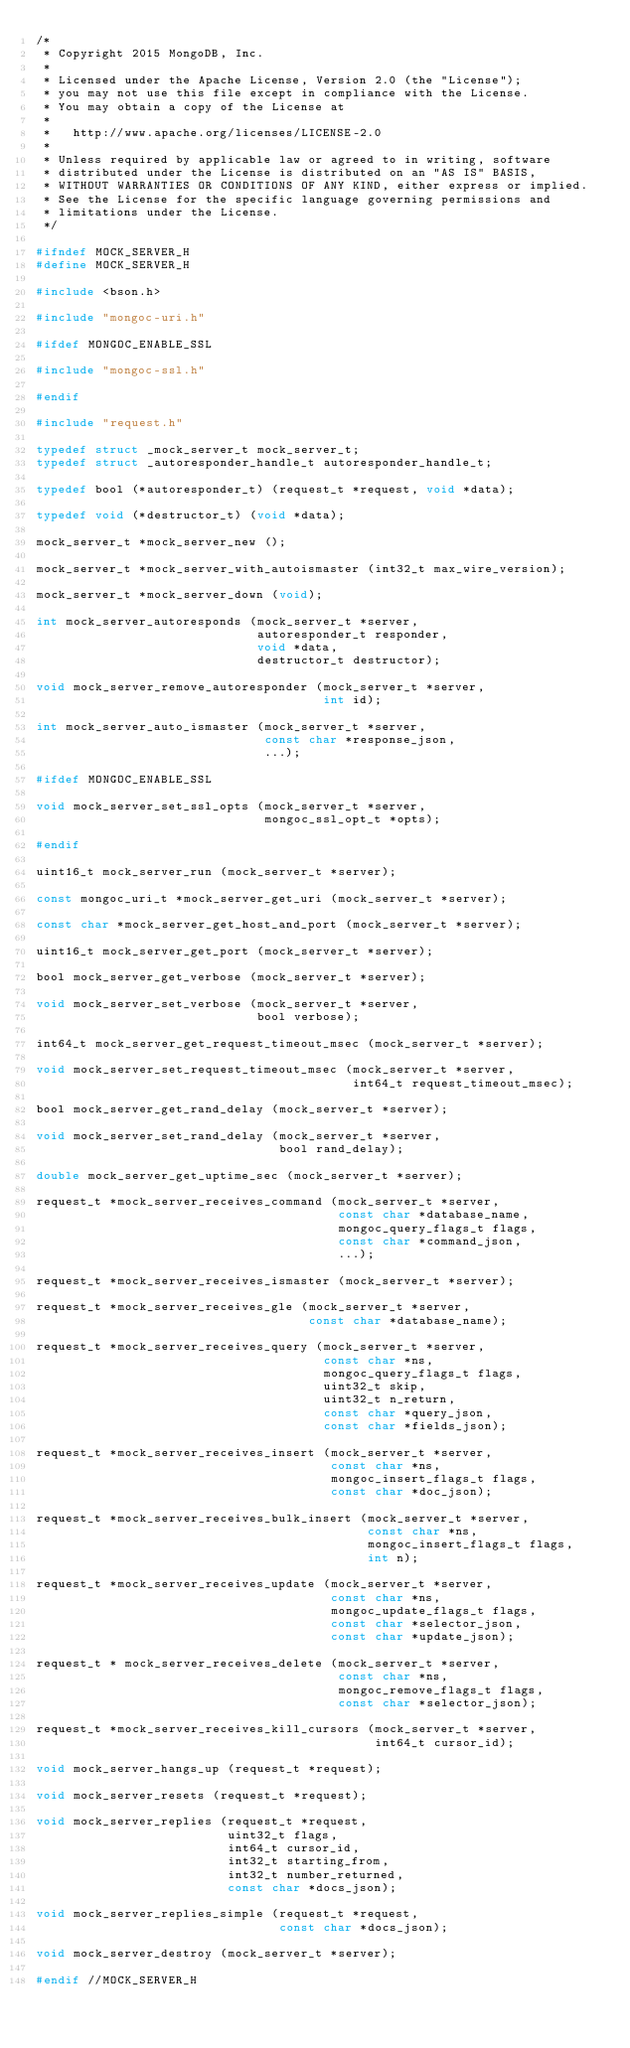<code> <loc_0><loc_0><loc_500><loc_500><_C_>/*
 * Copyright 2015 MongoDB, Inc.
 *
 * Licensed under the Apache License, Version 2.0 (the "License");
 * you may not use this file except in compliance with the License.
 * You may obtain a copy of the License at
 *
 *   http://www.apache.org/licenses/LICENSE-2.0
 *
 * Unless required by applicable law or agreed to in writing, software
 * distributed under the License is distributed on an "AS IS" BASIS,
 * WITHOUT WARRANTIES OR CONDITIONS OF ANY KIND, either express or implied.
 * See the License for the specific language governing permissions and
 * limitations under the License.
 */

#ifndef MOCK_SERVER_H
#define MOCK_SERVER_H

#include <bson.h>

#include "mongoc-uri.h"

#ifdef MONGOC_ENABLE_SSL

#include "mongoc-ssl.h"

#endif

#include "request.h"

typedef struct _mock_server_t mock_server_t;
typedef struct _autoresponder_handle_t autoresponder_handle_t;

typedef bool (*autoresponder_t) (request_t *request, void *data);

typedef void (*destructor_t) (void *data);

mock_server_t *mock_server_new ();

mock_server_t *mock_server_with_autoismaster (int32_t max_wire_version);

mock_server_t *mock_server_down (void);

int mock_server_autoresponds (mock_server_t *server,
                              autoresponder_t responder,
                              void *data,
                              destructor_t destructor);

void mock_server_remove_autoresponder (mock_server_t *server,
                                       int id);

int mock_server_auto_ismaster (mock_server_t *server,
                               const char *response_json,
                               ...);

#ifdef MONGOC_ENABLE_SSL

void mock_server_set_ssl_opts (mock_server_t *server,
                               mongoc_ssl_opt_t *opts);

#endif

uint16_t mock_server_run (mock_server_t *server);

const mongoc_uri_t *mock_server_get_uri (mock_server_t *server);

const char *mock_server_get_host_and_port (mock_server_t *server);

uint16_t mock_server_get_port (mock_server_t *server);

bool mock_server_get_verbose (mock_server_t *server);

void mock_server_set_verbose (mock_server_t *server,
                              bool verbose);

int64_t mock_server_get_request_timeout_msec (mock_server_t *server);

void mock_server_set_request_timeout_msec (mock_server_t *server,
                                           int64_t request_timeout_msec);

bool mock_server_get_rand_delay (mock_server_t *server);

void mock_server_set_rand_delay (mock_server_t *server,
                                 bool rand_delay);

double mock_server_get_uptime_sec (mock_server_t *server);

request_t *mock_server_receives_command (mock_server_t *server,
                                         const char *database_name,
                                         mongoc_query_flags_t flags,
                                         const char *command_json,
                                         ...);

request_t *mock_server_receives_ismaster (mock_server_t *server);

request_t *mock_server_receives_gle (mock_server_t *server,
                                     const char *database_name);

request_t *mock_server_receives_query (mock_server_t *server,
                                       const char *ns,
                                       mongoc_query_flags_t flags,
                                       uint32_t skip,
                                       uint32_t n_return,
                                       const char *query_json,
                                       const char *fields_json);

request_t *mock_server_receives_insert (mock_server_t *server,
                                        const char *ns,
                                        mongoc_insert_flags_t flags,
                                        const char *doc_json);

request_t *mock_server_receives_bulk_insert (mock_server_t *server,
                                             const char *ns,
                                             mongoc_insert_flags_t flags,
                                             int n);

request_t *mock_server_receives_update (mock_server_t *server,
                                        const char *ns,
                                        mongoc_update_flags_t flags,
                                        const char *selector_json,
                                        const char *update_json);

request_t * mock_server_receives_delete (mock_server_t *server,
                                         const char *ns,
                                         mongoc_remove_flags_t flags,
                                         const char *selector_json);

request_t *mock_server_receives_kill_cursors (mock_server_t *server,
                                              int64_t cursor_id);

void mock_server_hangs_up (request_t *request);

void mock_server_resets (request_t *request);

void mock_server_replies (request_t *request,
                          uint32_t flags,
                          int64_t cursor_id,
                          int32_t starting_from,
                          int32_t number_returned,
                          const char *docs_json);

void mock_server_replies_simple (request_t *request,
                                 const char *docs_json);

void mock_server_destroy (mock_server_t *server);

#endif //MOCK_SERVER_H
</code> 